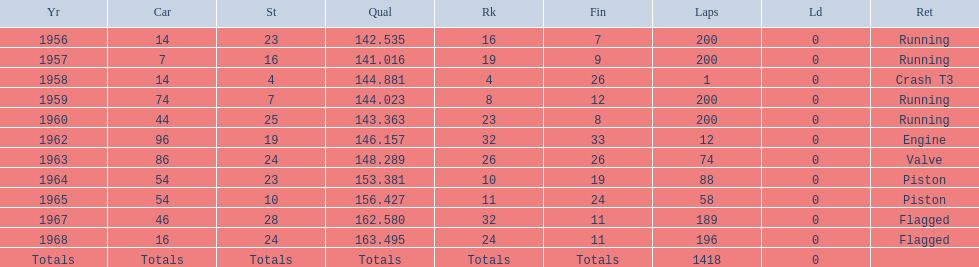How many times did he finish all 200 laps? 4. 